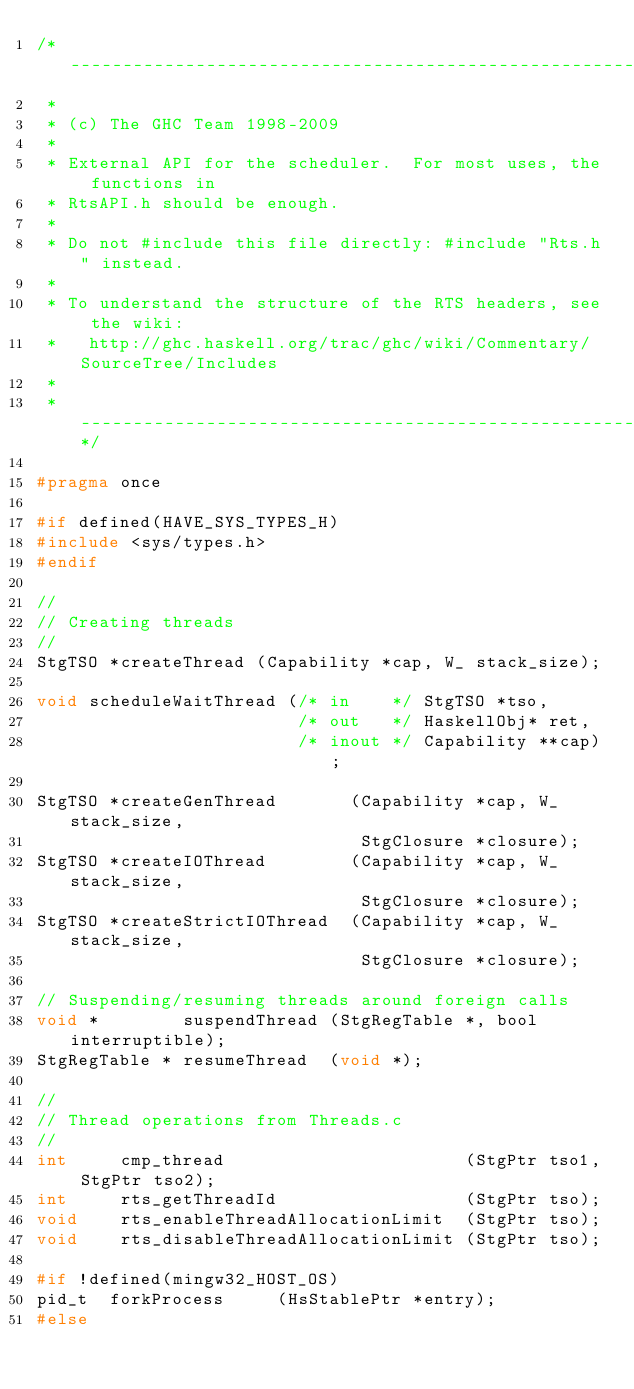Convert code to text. <code><loc_0><loc_0><loc_500><loc_500><_C_>/* -----------------------------------------------------------------------------
 *
 * (c) The GHC Team 1998-2009
 *
 * External API for the scheduler.  For most uses, the functions in
 * RtsAPI.h should be enough.
 *
 * Do not #include this file directly: #include "Rts.h" instead.
 *
 * To understand the structure of the RTS headers, see the wiki:
 *   http://ghc.haskell.org/trac/ghc/wiki/Commentary/SourceTree/Includes
 *
 * ---------------------------------------------------------------------------*/

#pragma once

#if defined(HAVE_SYS_TYPES_H)
#include <sys/types.h>
#endif

//
// Creating threads
//
StgTSO *createThread (Capability *cap, W_ stack_size);

void scheduleWaitThread (/* in    */ StgTSO *tso,
                         /* out   */ HaskellObj* ret,
                         /* inout */ Capability **cap);

StgTSO *createGenThread       (Capability *cap, W_ stack_size,
                               StgClosure *closure);
StgTSO *createIOThread        (Capability *cap, W_ stack_size,
                               StgClosure *closure);
StgTSO *createStrictIOThread  (Capability *cap, W_ stack_size,
                               StgClosure *closure);

// Suspending/resuming threads around foreign calls
void *        suspendThread (StgRegTable *, bool interruptible);
StgRegTable * resumeThread  (void *);

//
// Thread operations from Threads.c
//
int     cmp_thread                       (StgPtr tso1, StgPtr tso2);
int     rts_getThreadId                  (StgPtr tso);
void    rts_enableThreadAllocationLimit  (StgPtr tso);
void    rts_disableThreadAllocationLimit (StgPtr tso);

#if !defined(mingw32_HOST_OS)
pid_t  forkProcess     (HsStablePtr *entry);
#else</code> 